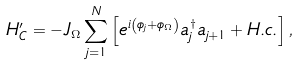Convert formula to latex. <formula><loc_0><loc_0><loc_500><loc_500>H _ { C } ^ { \prime } = - J _ { \Omega } \sum _ { j = 1 } ^ { N } \left [ e ^ { i \left ( \phi _ { j } + \phi _ { \Omega } \right ) } a _ { j } ^ { \dag } a _ { j + 1 } + H . c . \right ] ,</formula> 